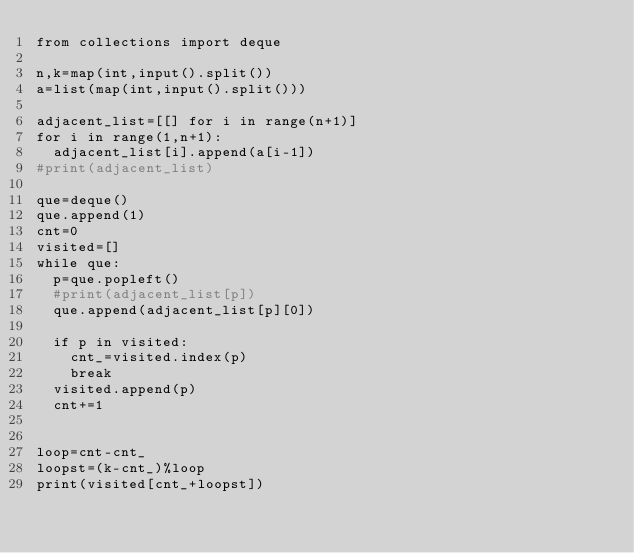<code> <loc_0><loc_0><loc_500><loc_500><_Python_>from collections import deque

n,k=map(int,input().split())
a=list(map(int,input().split()))

adjacent_list=[[] for i in range(n+1)]
for i in range(1,n+1):
  adjacent_list[i].append(a[i-1])
#print(adjacent_list)

que=deque()
que.append(1)
cnt=0
visited=[]
while que:
  p=que.popleft()
  #print(adjacent_list[p])
  que.append(adjacent_list[p][0])
  
  if p in visited:
    cnt_=visited.index(p)
    break
  visited.append(p)
  cnt+=1
  

loop=cnt-cnt_
loopst=(k-cnt_)%loop
print(visited[cnt_+loopst])</code> 